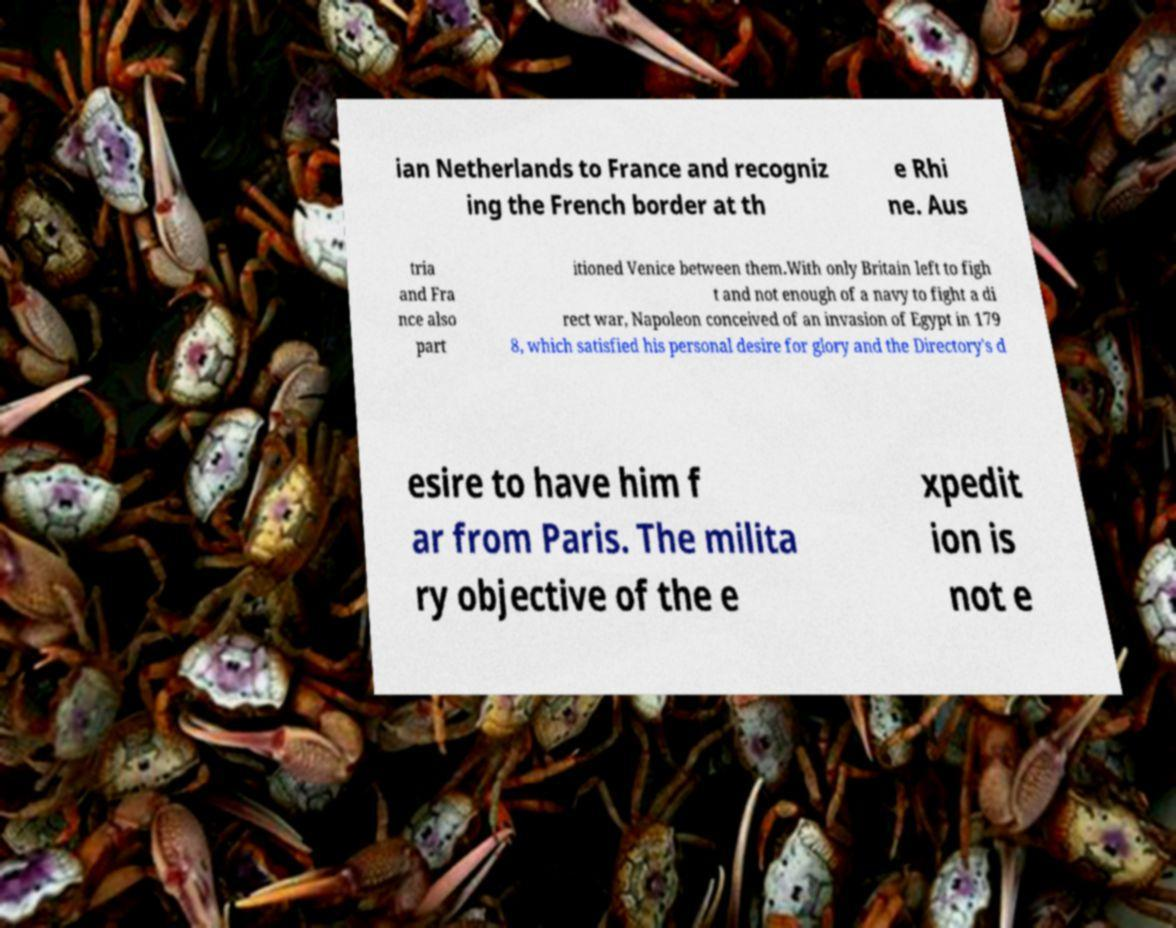I need the written content from this picture converted into text. Can you do that? ian Netherlands to France and recogniz ing the French border at th e Rhi ne. Aus tria and Fra nce also part itioned Venice between them.With only Britain left to figh t and not enough of a navy to fight a di rect war, Napoleon conceived of an invasion of Egypt in 179 8, which satisfied his personal desire for glory and the Directory's d esire to have him f ar from Paris. The milita ry objective of the e xpedit ion is not e 